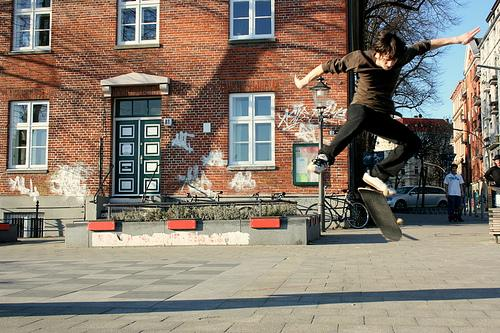The concrete planter has how many orange boards on the side?

Choices:
A) two
B) five
C) four
D) three three 